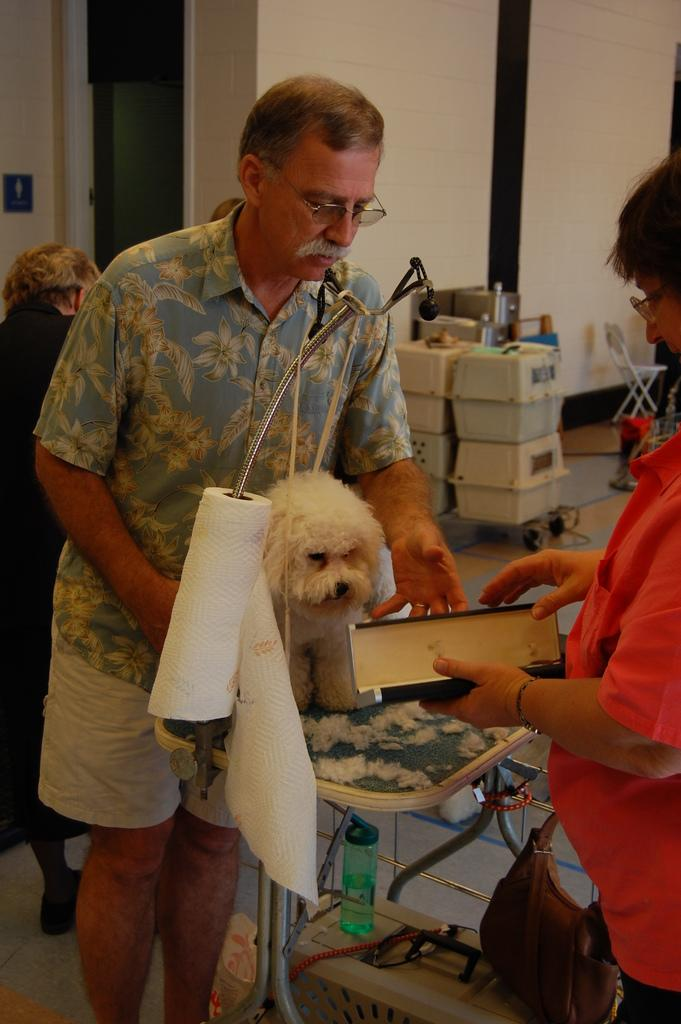What can be seen in the image in terms of living beings? There are people standing in the image, and a dog is also present. What else is visible in the image besides the people and the dog? There are other objects in the image, including boxes. What type of prose is being recited by the dog in the image? There is no indication in the image that the dog is reciting any prose, as dogs do not have the ability to speak or recite literature. 